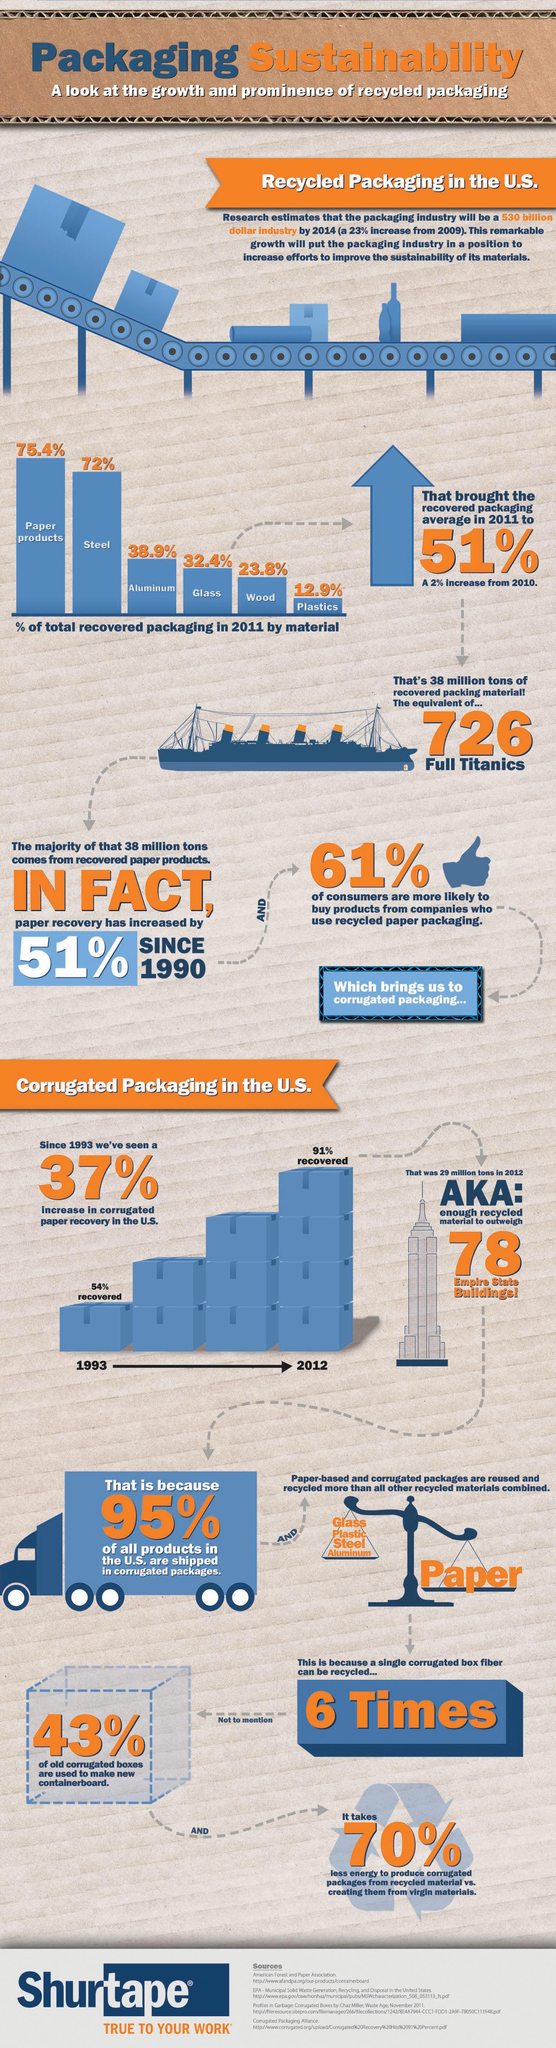Point out several critical features in this image. According to data from 2012, 91% of corrugated paper recovery was achieved in the United States. In 1993, approximately 54% of corrugated paper recovery was achieved in the United States. In 2011, approximately 72% of the total recovered packaging in the U.S. was composed of steel. According to data, only 5% of all products sold in the United States are not shipped in corrugated packages. In 2011, a significant 39% of consumers in the U.S. stated that they did not intend to purchase products from companies that used recycled paper packaging. 